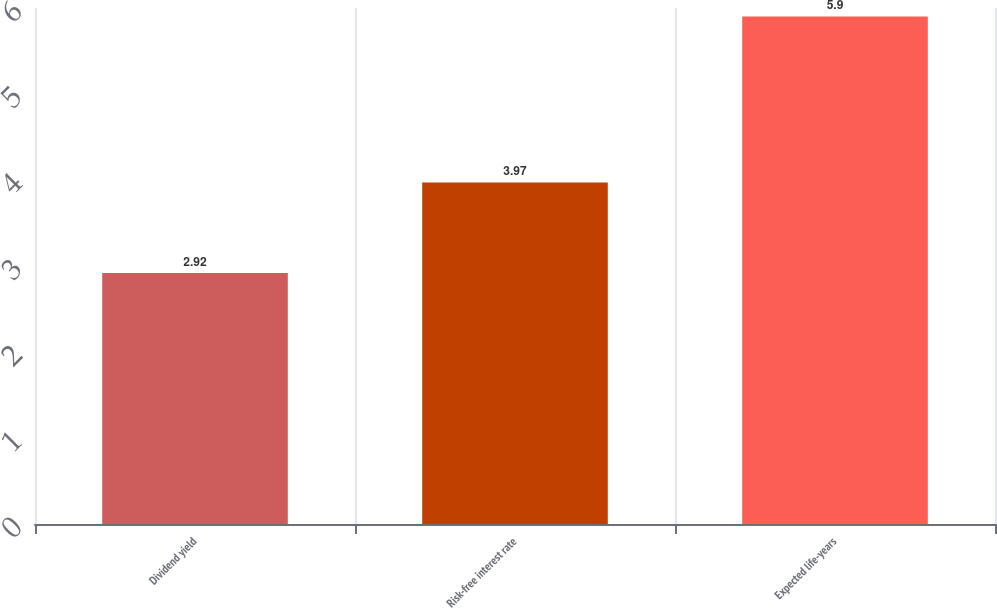Convert chart. <chart><loc_0><loc_0><loc_500><loc_500><bar_chart><fcel>Dividend yield<fcel>Risk-free interest rate<fcel>Expected life-years<nl><fcel>2.92<fcel>3.97<fcel>5.9<nl></chart> 